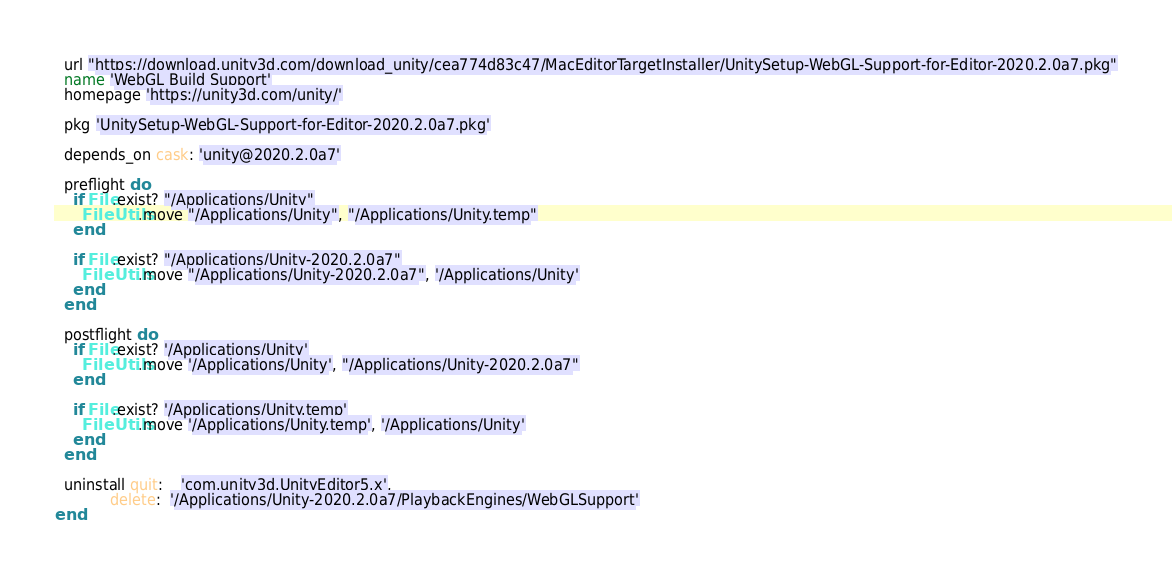Convert code to text. <code><loc_0><loc_0><loc_500><loc_500><_Ruby_>
  url "https://download.unity3d.com/download_unity/cea774d83c47/MacEditorTargetInstaller/UnitySetup-WebGL-Support-for-Editor-2020.2.0a7.pkg"
  name 'WebGL Build Support'
  homepage 'https://unity3d.com/unity/'

  pkg 'UnitySetup-WebGL-Support-for-Editor-2020.2.0a7.pkg'

  depends_on cask: 'unity@2020.2.0a7'

  preflight do
    if File.exist? "/Applications/Unity"
      FileUtils.move "/Applications/Unity", "/Applications/Unity.temp"
    end

    if File.exist? "/Applications/Unity-2020.2.0a7"
      FileUtils.move "/Applications/Unity-2020.2.0a7", '/Applications/Unity'
    end
  end

  postflight do
    if File.exist? '/Applications/Unity'
      FileUtils.move '/Applications/Unity', "/Applications/Unity-2020.2.0a7"
    end

    if File.exist? '/Applications/Unity.temp'
      FileUtils.move '/Applications/Unity.temp', '/Applications/Unity'
    end
  end

  uninstall quit:    'com.unity3d.UnityEditor5.x',
            delete:  '/Applications/Unity-2020.2.0a7/PlaybackEngines/WebGLSupport'
end
</code> 